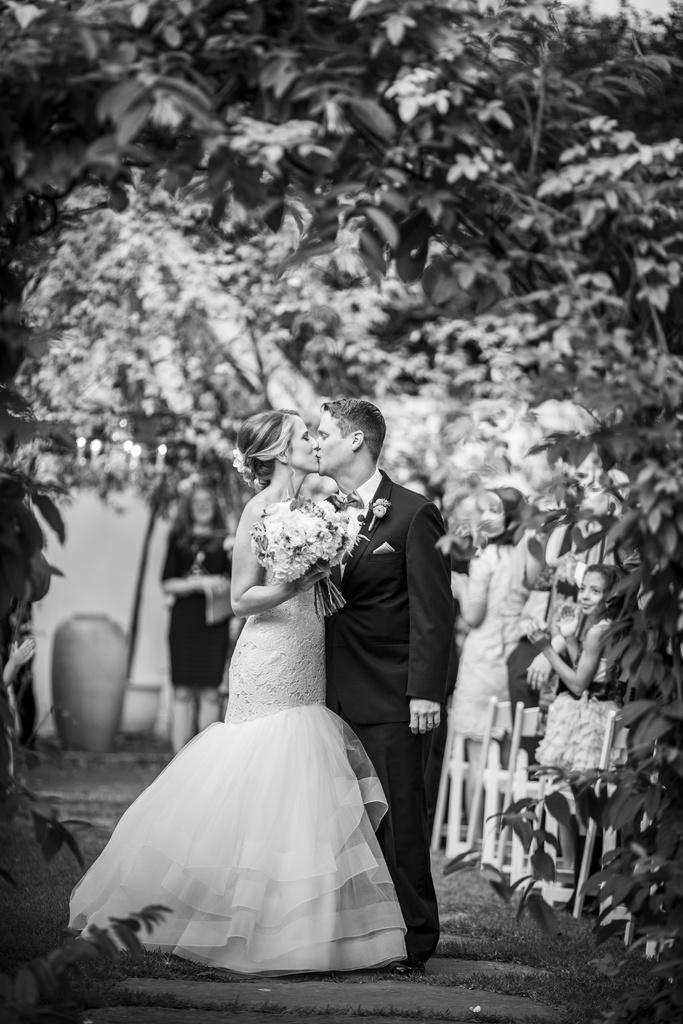How would you summarize this image in a sentence or two? In this image, I can see a woman and a woman and both of them are kissing and both of them are standing on a path. The woman is holding flowers. In the background there is a lot of decoration and few people over here. 